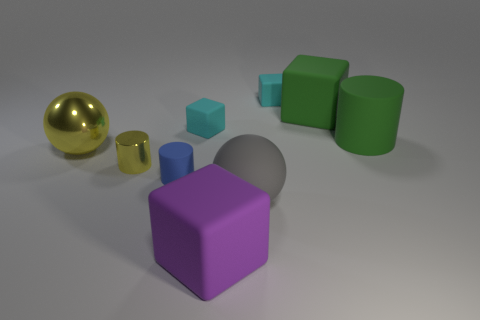Subtract all cubes. How many objects are left? 5 Subtract 0 gray cylinders. How many objects are left? 9 Subtract all big purple metallic cylinders. Subtract all small things. How many objects are left? 5 Add 7 small cyan cubes. How many small cyan cubes are left? 9 Add 5 tiny gray rubber spheres. How many tiny gray rubber spheres exist? 5 